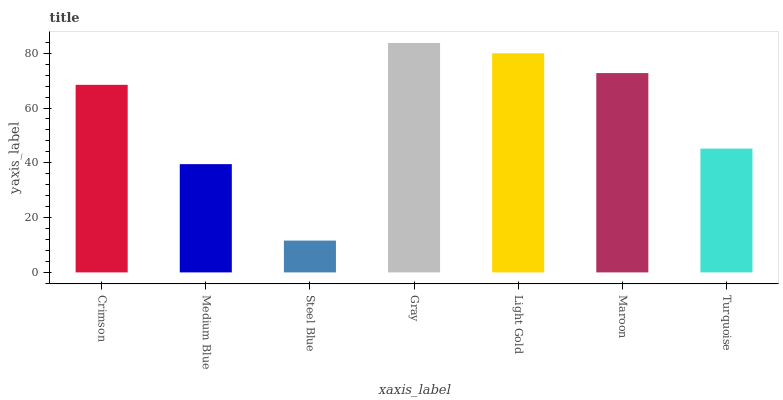Is Medium Blue the minimum?
Answer yes or no. No. Is Medium Blue the maximum?
Answer yes or no. No. Is Crimson greater than Medium Blue?
Answer yes or no. Yes. Is Medium Blue less than Crimson?
Answer yes or no. Yes. Is Medium Blue greater than Crimson?
Answer yes or no. No. Is Crimson less than Medium Blue?
Answer yes or no. No. Is Crimson the high median?
Answer yes or no. Yes. Is Crimson the low median?
Answer yes or no. Yes. Is Medium Blue the high median?
Answer yes or no. No. Is Turquoise the low median?
Answer yes or no. No. 